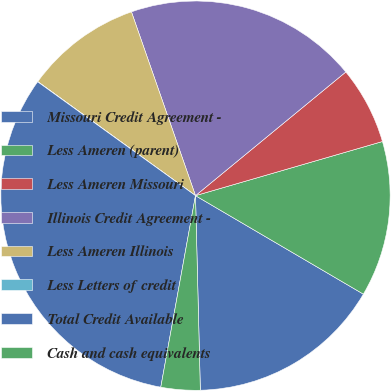<chart> <loc_0><loc_0><loc_500><loc_500><pie_chart><fcel>Missouri Credit Agreement -<fcel>Less Ameren (parent)<fcel>Less Ameren Missouri<fcel>Illinois Credit Agreement -<fcel>Less Ameren Illinois<fcel>Less Letters of credit<fcel>Total Credit Available<fcel>Cash and cash equivalents<nl><fcel>16.16%<fcel>12.93%<fcel>6.47%<fcel>19.38%<fcel>9.7%<fcel>0.02%<fcel>32.09%<fcel>3.25%<nl></chart> 